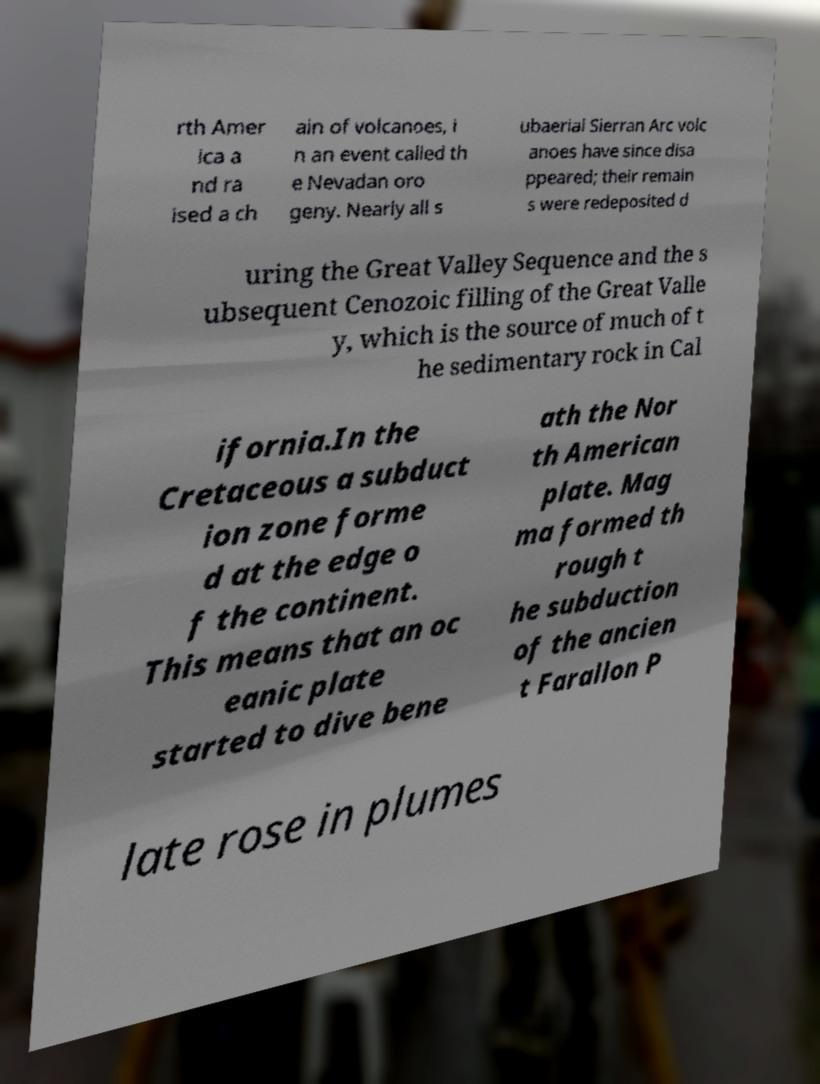Please identify and transcribe the text found in this image. rth Amer ica a nd ra ised a ch ain of volcanoes, i n an event called th e Nevadan oro geny. Nearly all s ubaerial Sierran Arc volc anoes have since disa ppeared; their remain s were redeposited d uring the Great Valley Sequence and the s ubsequent Cenozoic filling of the Great Valle y, which is the source of much of t he sedimentary rock in Cal ifornia.In the Cretaceous a subduct ion zone forme d at the edge o f the continent. This means that an oc eanic plate started to dive bene ath the Nor th American plate. Mag ma formed th rough t he subduction of the ancien t Farallon P late rose in plumes 